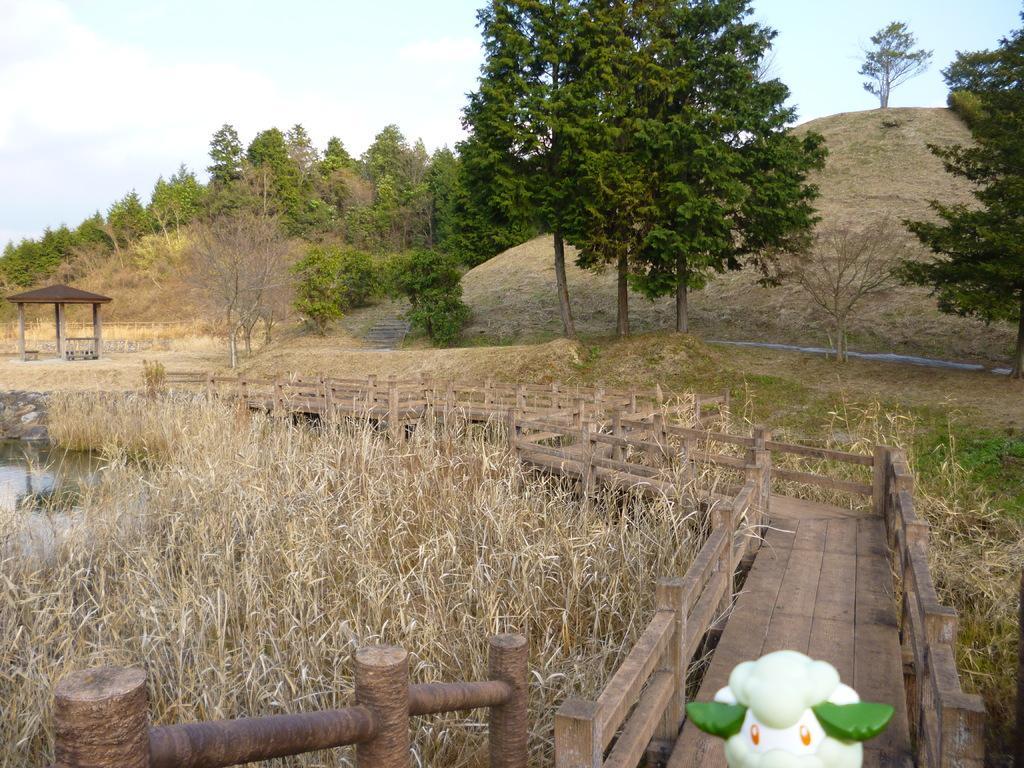Can you describe this image briefly? In this image we can see a walkway bridge, lawn straw, hills, trees and sky with clouds. 